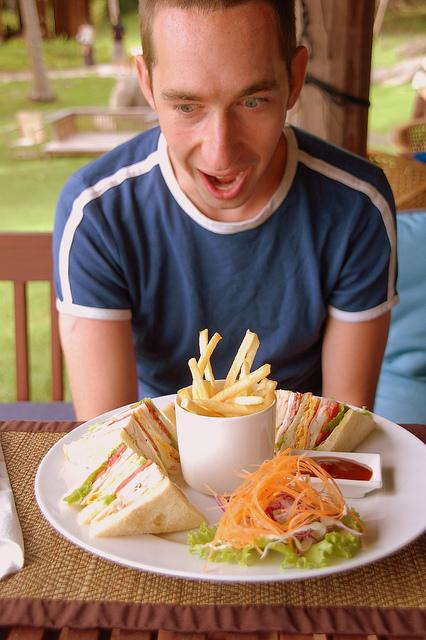Is the guy looking forward to his meal?
Keep it brief. Yes. Are these cold cuts?
Give a very brief answer. Yes. What condiment is in the white package?
Give a very brief answer. Ketchup. Is this a Mexican dinner?
Keep it brief. No. Where are the men's sunglasses?
Write a very short answer. Head. What kind of silverware is on his plate?
Give a very brief answer. None. What kind of sandwich is pictured here?
Short answer required. Club. How many hot dogs are on his plate?
Give a very brief answer. 0. 